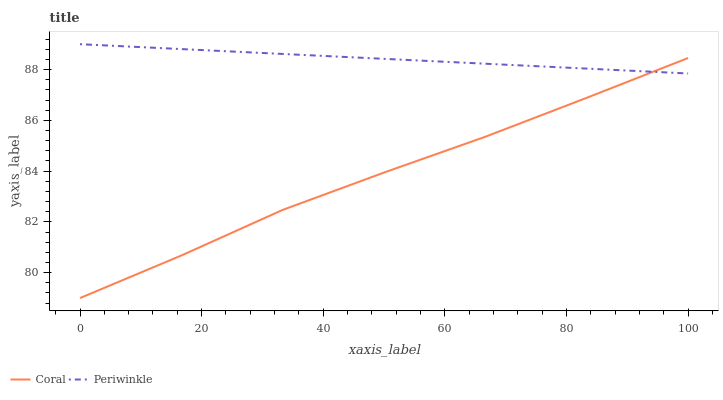Does Coral have the minimum area under the curve?
Answer yes or no. Yes. Does Periwinkle have the maximum area under the curve?
Answer yes or no. Yes. Does Periwinkle have the minimum area under the curve?
Answer yes or no. No. Is Periwinkle the smoothest?
Answer yes or no. Yes. Is Coral the roughest?
Answer yes or no. Yes. Is Periwinkle the roughest?
Answer yes or no. No. Does Coral have the lowest value?
Answer yes or no. Yes. Does Periwinkle have the lowest value?
Answer yes or no. No. Does Periwinkle have the highest value?
Answer yes or no. Yes. Does Periwinkle intersect Coral?
Answer yes or no. Yes. Is Periwinkle less than Coral?
Answer yes or no. No. Is Periwinkle greater than Coral?
Answer yes or no. No. 